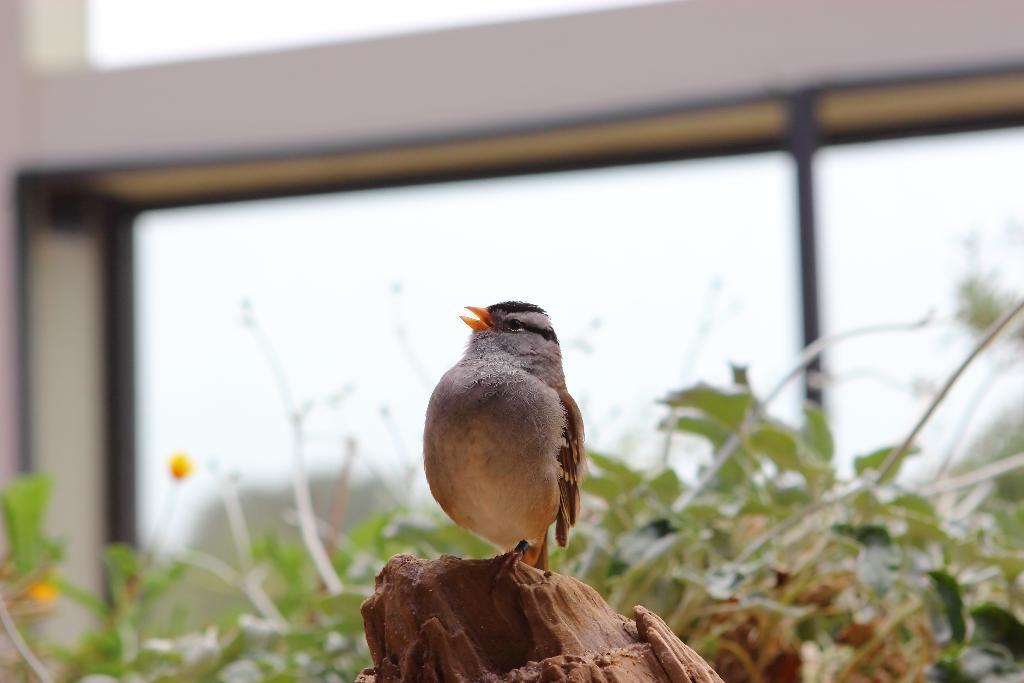Can you describe this image briefly? In this image in the foreground there is one bird which is on a tree, and in the background there are some plants, glass window and wall. 